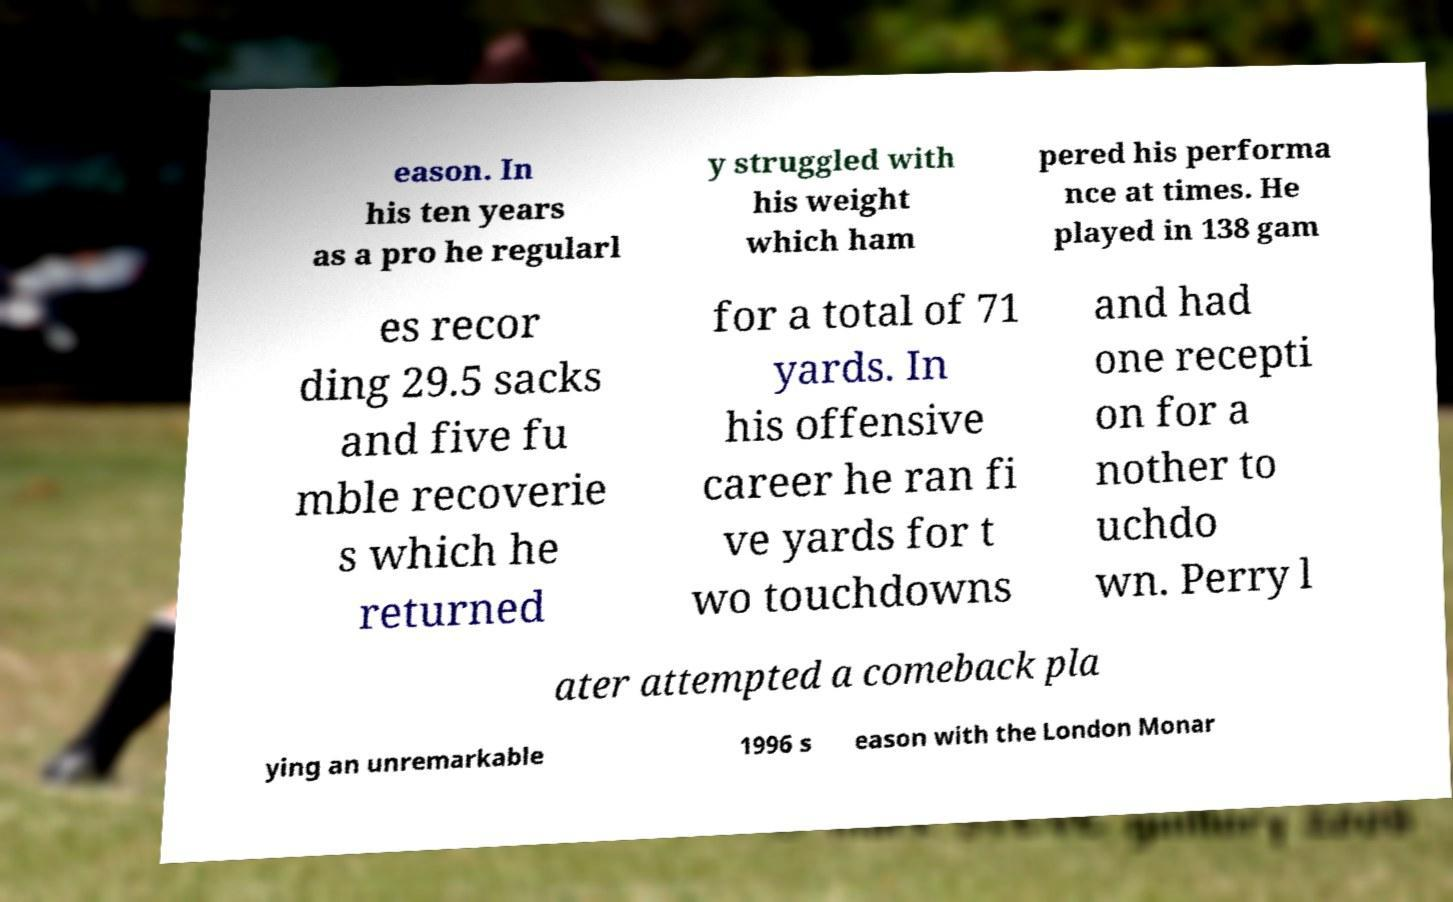Could you assist in decoding the text presented in this image and type it out clearly? eason. In his ten years as a pro he regularl y struggled with his weight which ham pered his performa nce at times. He played in 138 gam es recor ding 29.5 sacks and five fu mble recoverie s which he returned for a total of 71 yards. In his offensive career he ran fi ve yards for t wo touchdowns and had one recepti on for a nother to uchdo wn. Perry l ater attempted a comeback pla ying an unremarkable 1996 s eason with the London Monar 